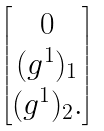Convert formula to latex. <formula><loc_0><loc_0><loc_500><loc_500>\begin{bmatrix} 0 \\ ( g ^ { 1 } ) _ { 1 } \\ ( g ^ { 1 } ) _ { 2 } . \end{bmatrix}</formula> 